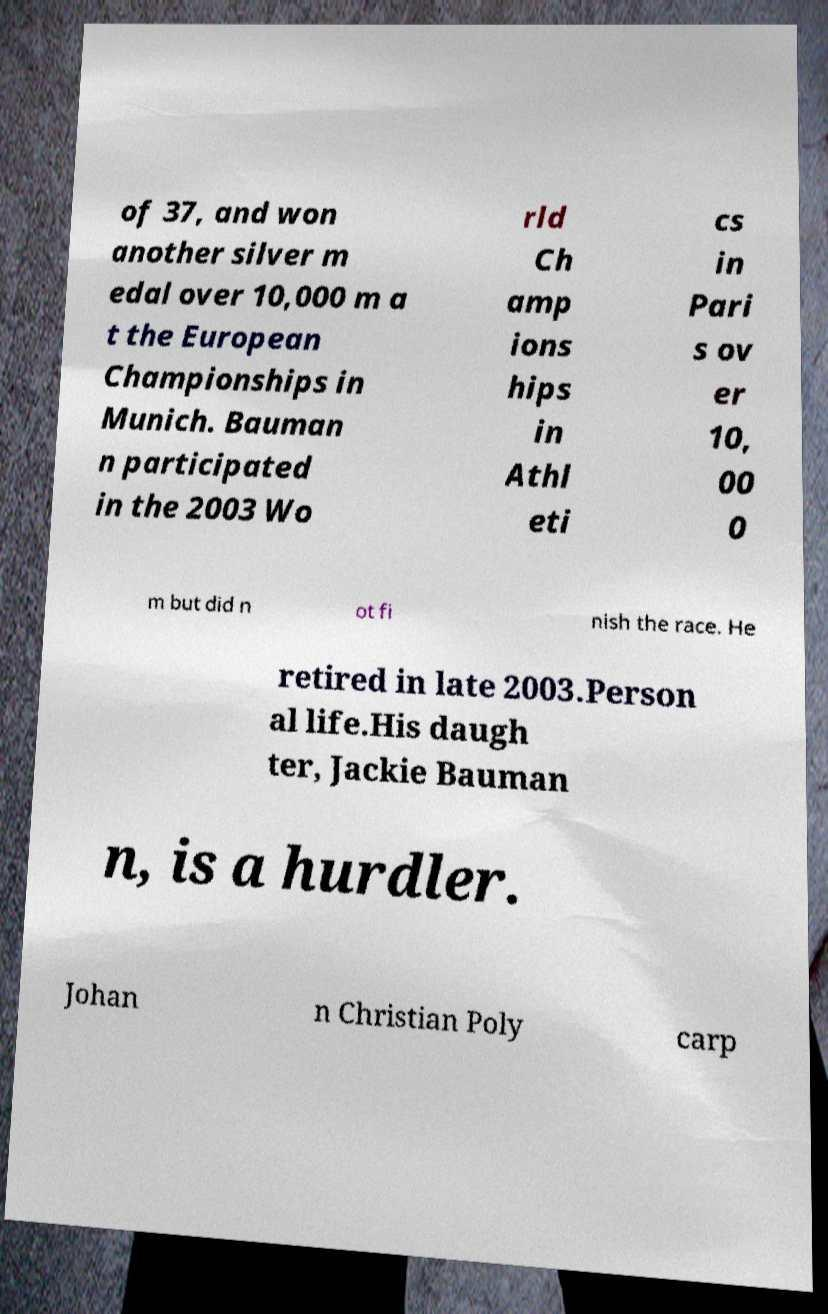Could you assist in decoding the text presented in this image and type it out clearly? of 37, and won another silver m edal over 10,000 m a t the European Championships in Munich. Bauman n participated in the 2003 Wo rld Ch amp ions hips in Athl eti cs in Pari s ov er 10, 00 0 m but did n ot fi nish the race. He retired in late 2003.Person al life.His daugh ter, Jackie Bauman n, is a hurdler. Johan n Christian Poly carp 